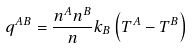<formula> <loc_0><loc_0><loc_500><loc_500>q ^ { A B } = \frac { n ^ { A } n ^ { B } } n k _ { B } \left ( T ^ { A } - T ^ { B } \right )</formula> 